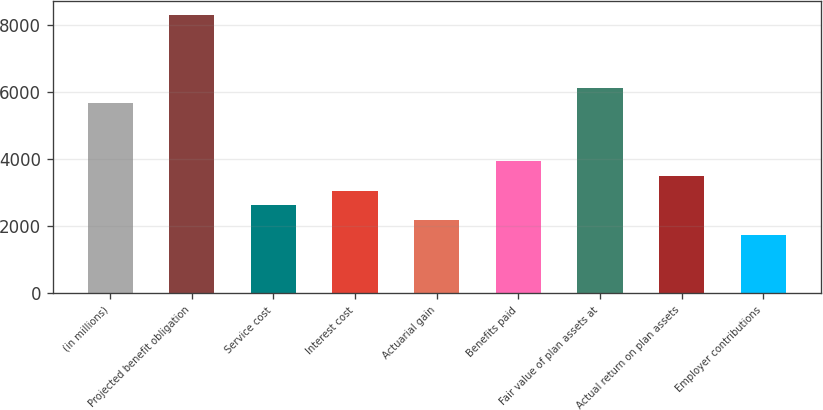<chart> <loc_0><loc_0><loc_500><loc_500><bar_chart><fcel>(in millions)<fcel>Projected benefit obligation<fcel>Service cost<fcel>Interest cost<fcel>Actuarial gain<fcel>Benefits paid<fcel>Fair value of plan assets at<fcel>Actual return on plan assets<fcel>Employer contributions<nl><fcel>5685.07<fcel>8307.13<fcel>2626<fcel>3063.01<fcel>2188.99<fcel>3937.03<fcel>6122.08<fcel>3500.02<fcel>1751.98<nl></chart> 